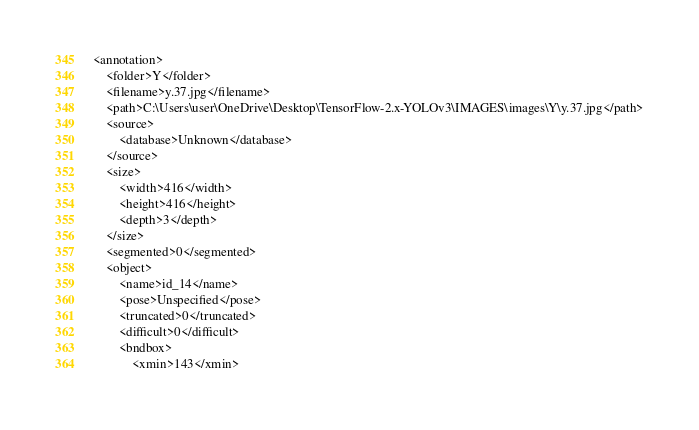Convert code to text. <code><loc_0><loc_0><loc_500><loc_500><_XML_><annotation>
	<folder>Y</folder>
	<filename>y.37.jpg</filename>
	<path>C:\Users\user\OneDrive\Desktop\TensorFlow-2.x-YOLOv3\IMAGES\images\Y\y.37.jpg</path>
	<source>
		<database>Unknown</database>
	</source>
	<size>
		<width>416</width>
		<height>416</height>
		<depth>3</depth>
	</size>
	<segmented>0</segmented>
	<object>
		<name>id_14</name>
		<pose>Unspecified</pose>
		<truncated>0</truncated>
		<difficult>0</difficult>
		<bndbox>
			<xmin>143</xmin></code> 